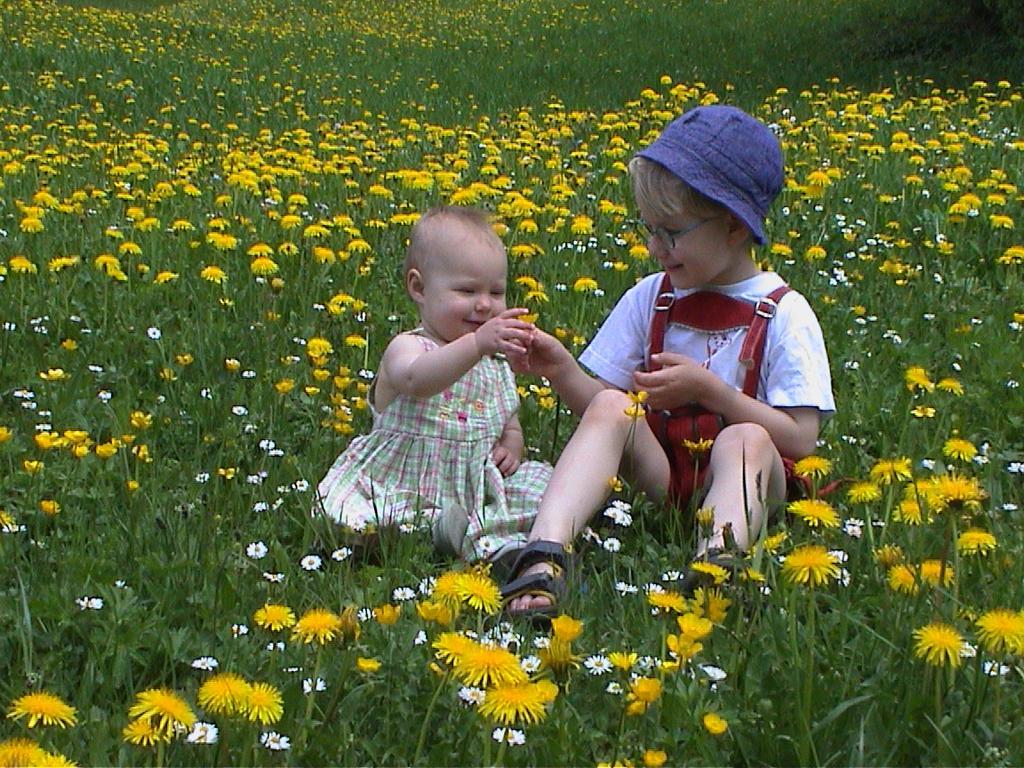Could you give a brief overview of what you see in this image? In this image there is one boy sitting at right side is wearing white color t shirt and blue color cap. There is one baby sitting at left side of this image and there are some yellow color and white color flowers in the background. 